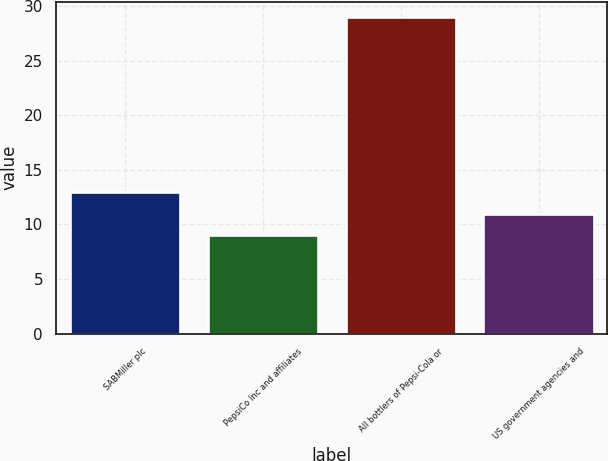Convert chart. <chart><loc_0><loc_0><loc_500><loc_500><bar_chart><fcel>SABMiller plc<fcel>PepsiCo Inc and affiliates<fcel>All bottlers of Pepsi-Cola or<fcel>US government agencies and<nl><fcel>13<fcel>9<fcel>29<fcel>11<nl></chart> 